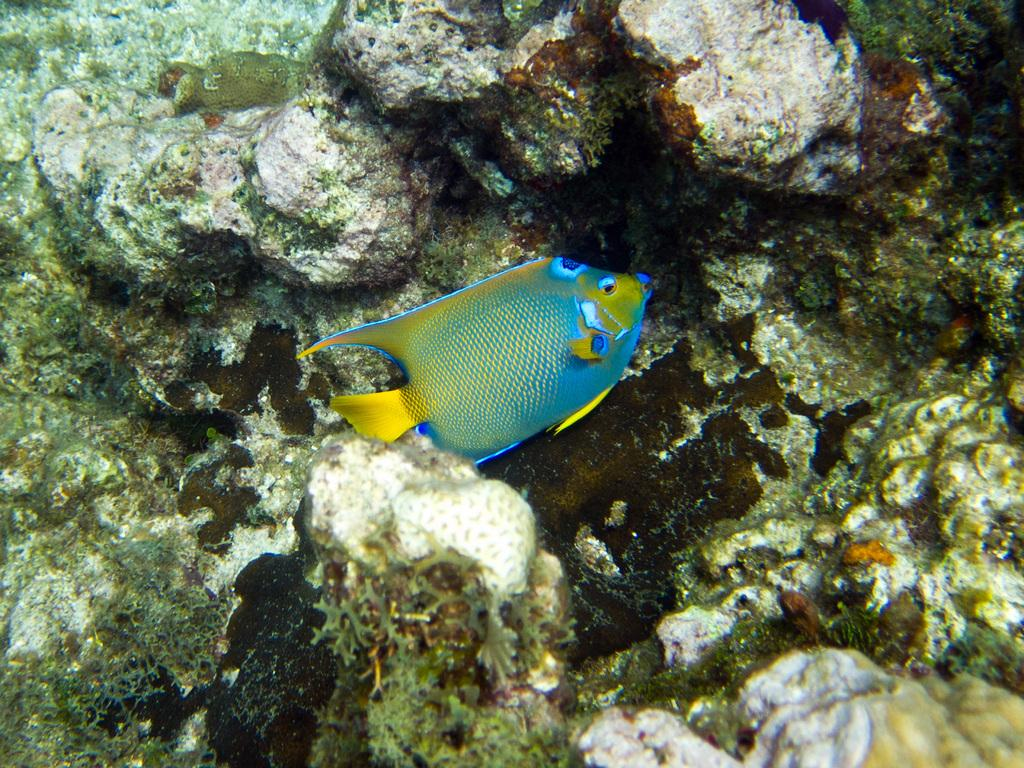What type of animals can be seen in the image? There are fish in the image. What natural formation is visible in the image? There are coral reefs in the image. In what environment are the fish and coral reefs located? The fish and coral reefs are in water. How many apples are floating near the coral reefs in the image? There are no apples present in the image; it features fish and coral reefs in water. 